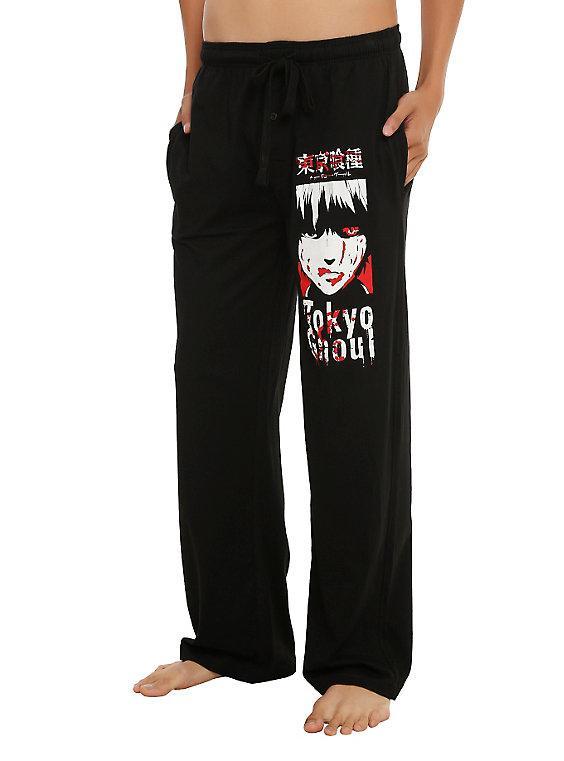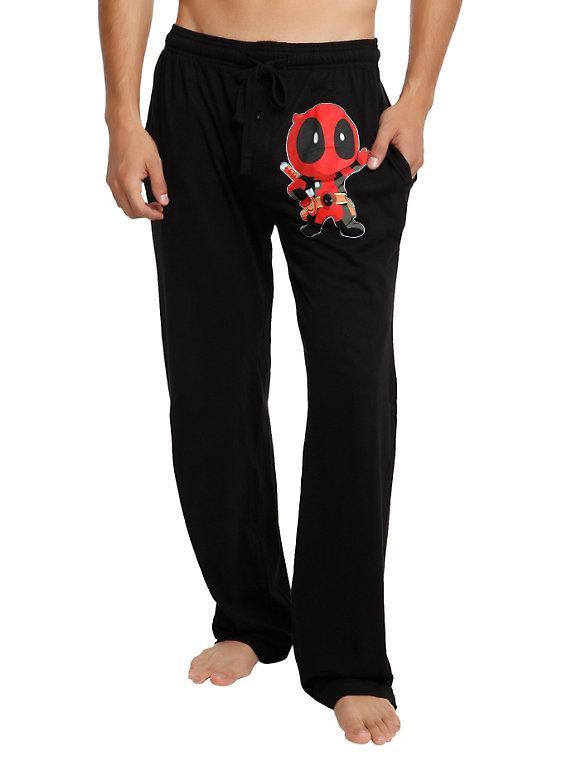The first image is the image on the left, the second image is the image on the right. Analyze the images presented: Is the assertion "The pants do not have a repeating pattern on them." valid? Answer yes or no. Yes. 